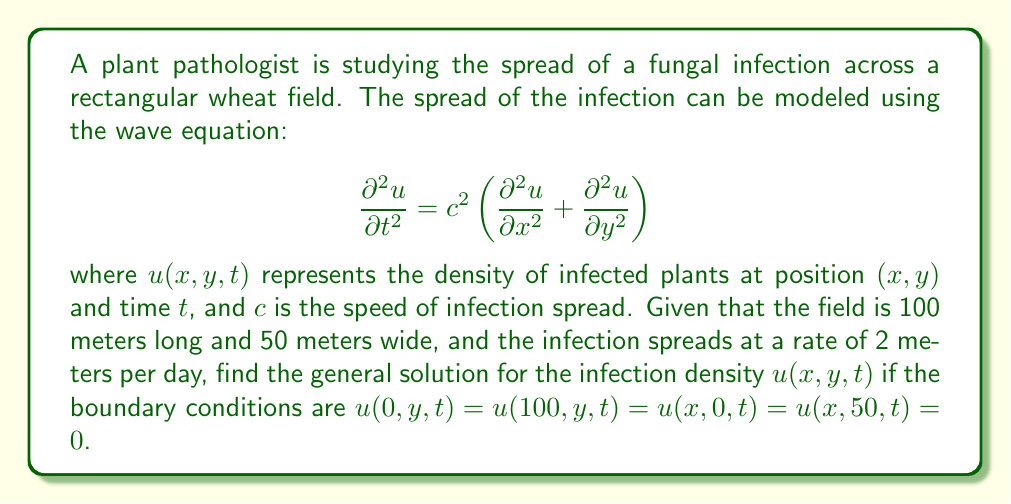Can you answer this question? To solve this problem, we'll use the method of separation of variables and follow these steps:

1) Assume the solution has the form: $u(x,y,t) = X(x)Y(y)T(t)$

2) Substitute this into the wave equation:

   $$X(x)Y(y)T''(t) = c^2[X''(x)Y(y)T(t) + X(x)Y''(y)T(t)]$$

3) Divide both sides by $X(x)Y(y)T(t)$:

   $$\frac{T''(t)}{T(t)} = c^2\left(\frac{X''(x)}{X(x)} + \frac{Y''(y)}{Y(y)}\right)$$

4) The left side is a function of $t$ only, and the right side is a function of $x$ and $y$ only. For this to be true for all $x$, $y$, and $t$, both sides must equal a constant. Let's call this constant $-\omega^2$:

   $$\frac{T''(t)}{T(t)} = -\omega^2$$
   $$c^2\left(\frac{X''(x)}{X(x)} + \frac{Y''(y)}{Y(y)}\right) = -\omega^2$$

5) From the second equation, we can further separate $x$ and $y$:

   $$\frac{X''(x)}{X(x)} = -k^2$$
   $$\frac{Y''(y)}{Y(y)} = -l^2$$
   
   where $c^2(k^2 + l^2) = \omega^2$

6) Now we have three separate ODEs:

   $T''(t) + \omega^2T(t) = 0$
   $X''(x) + k^2X(x) = 0$
   $Y''(y) + l^2Y(y) = 0$

7) The general solutions to these equations are:

   $T(t) = A\cos(\omega t) + B\sin(\omega t)$
   $X(x) = C\cos(kx) + D\sin(kx)$
   $Y(y) = E\cos(ly) + F\sin(ly)$

8) Apply the boundary conditions:

   $u(0,y,t) = 0$ implies $X(0) = 0$, so $C = 0$
   $u(100,y,t) = 0$ implies $X(100) = 0$, so $k = \frac{n\pi}{100}$, where $n$ is a positive integer
   
   $u(x,0,t) = 0$ implies $Y(0) = 0$, so $E = 0$
   $u(x,50,t) = 0$ implies $Y(50) = 0$, so $l = \frac{m\pi}{50}$, where $m$ is a positive integer

9) The general solution is therefore:

   $$u(x,y,t) = \sum_{n=1}^{\infty}\sum_{m=1}^{\infty} [A_{nm}\cos(\omega_{nm}t) + B_{nm}\sin(\omega_{nm}t)] \sin(\frac{n\pi x}{100})\sin(\frac{m\pi y}{50})$$

   where $\omega_{nm} = c\sqrt{(\frac{n\pi}{100})^2 + (\frac{m\pi}{50})^2}$ and $c = 2$ meters/day.

This solution satisfies the wave equation and all boundary conditions.
Answer: The general solution for the infection density is:

$$u(x,y,t) = \sum_{n=1}^{\infty}\sum_{m=1}^{\infty} [A_{nm}\cos(\omega_{nm}t) + B_{nm}\sin(\omega_{nm}t)] \sin(\frac{n\pi x}{100})\sin(\frac{m\pi y}{50})$$

where $\omega_{nm} = 2\sqrt{(\frac{n\pi}{100})^2 + (\frac{m\pi}{50})^2}$, and $A_{nm}$ and $B_{nm}$ are constants determined by initial conditions. 